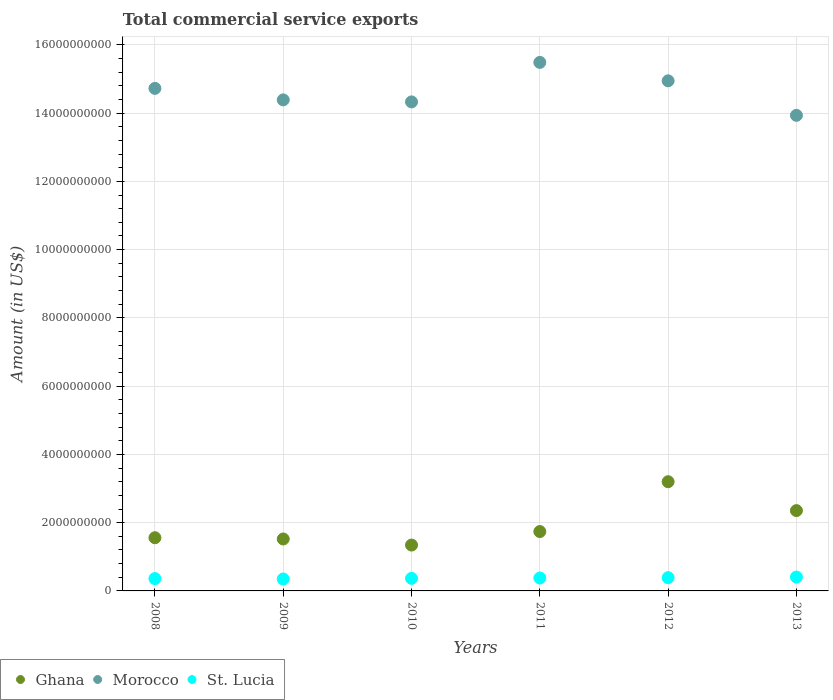How many different coloured dotlines are there?
Offer a terse response. 3. Is the number of dotlines equal to the number of legend labels?
Offer a very short reply. Yes. What is the total commercial service exports in Morocco in 2012?
Ensure brevity in your answer.  1.49e+1. Across all years, what is the maximum total commercial service exports in Ghana?
Make the answer very short. 3.20e+09. Across all years, what is the minimum total commercial service exports in Morocco?
Provide a short and direct response. 1.39e+1. In which year was the total commercial service exports in Ghana maximum?
Your response must be concise. 2012. What is the total total commercial service exports in St. Lucia in the graph?
Make the answer very short. 2.25e+09. What is the difference between the total commercial service exports in Ghana in 2008 and that in 2010?
Keep it short and to the point. 2.15e+08. What is the difference between the total commercial service exports in Ghana in 2009 and the total commercial service exports in Morocco in 2012?
Offer a very short reply. -1.34e+1. What is the average total commercial service exports in Morocco per year?
Provide a short and direct response. 1.46e+1. In the year 2008, what is the difference between the total commercial service exports in St. Lucia and total commercial service exports in Morocco?
Provide a short and direct response. -1.44e+1. What is the ratio of the total commercial service exports in Morocco in 2008 to that in 2009?
Give a very brief answer. 1.02. What is the difference between the highest and the second highest total commercial service exports in Ghana?
Provide a short and direct response. 8.47e+08. What is the difference between the highest and the lowest total commercial service exports in St. Lucia?
Offer a very short reply. 5.57e+07. Is the sum of the total commercial service exports in Morocco in 2008 and 2011 greater than the maximum total commercial service exports in Ghana across all years?
Ensure brevity in your answer.  Yes. Is the total commercial service exports in Morocco strictly greater than the total commercial service exports in Ghana over the years?
Keep it short and to the point. Yes. How many years are there in the graph?
Offer a very short reply. 6. What is the difference between two consecutive major ticks on the Y-axis?
Provide a succinct answer. 2.00e+09. Does the graph contain grids?
Your answer should be compact. Yes. Where does the legend appear in the graph?
Ensure brevity in your answer.  Bottom left. How many legend labels are there?
Make the answer very short. 3. How are the legend labels stacked?
Ensure brevity in your answer.  Horizontal. What is the title of the graph?
Offer a very short reply. Total commercial service exports. Does "Australia" appear as one of the legend labels in the graph?
Offer a terse response. No. What is the label or title of the Y-axis?
Provide a succinct answer. Amount (in US$). What is the Amount (in US$) in Ghana in 2008?
Provide a succinct answer. 1.56e+09. What is the Amount (in US$) of Morocco in 2008?
Your answer should be very brief. 1.47e+1. What is the Amount (in US$) in St. Lucia in 2008?
Ensure brevity in your answer.  3.62e+08. What is the Amount (in US$) of Ghana in 2009?
Your answer should be very brief. 1.52e+09. What is the Amount (in US$) in Morocco in 2009?
Provide a short and direct response. 1.44e+1. What is the Amount (in US$) in St. Lucia in 2009?
Ensure brevity in your answer.  3.50e+08. What is the Amount (in US$) of Ghana in 2010?
Your response must be concise. 1.34e+09. What is the Amount (in US$) of Morocco in 2010?
Provide a succinct answer. 1.43e+1. What is the Amount (in US$) of St. Lucia in 2010?
Offer a very short reply. 3.68e+08. What is the Amount (in US$) of Ghana in 2011?
Provide a short and direct response. 1.74e+09. What is the Amount (in US$) of Morocco in 2011?
Your answer should be very brief. 1.55e+1. What is the Amount (in US$) of St. Lucia in 2011?
Give a very brief answer. 3.78e+08. What is the Amount (in US$) of Ghana in 2012?
Make the answer very short. 3.20e+09. What is the Amount (in US$) in Morocco in 2012?
Offer a terse response. 1.49e+1. What is the Amount (in US$) in St. Lucia in 2012?
Make the answer very short. 3.89e+08. What is the Amount (in US$) in Ghana in 2013?
Ensure brevity in your answer.  2.35e+09. What is the Amount (in US$) of Morocco in 2013?
Provide a short and direct response. 1.39e+1. What is the Amount (in US$) of St. Lucia in 2013?
Provide a succinct answer. 4.06e+08. Across all years, what is the maximum Amount (in US$) of Ghana?
Your response must be concise. 3.20e+09. Across all years, what is the maximum Amount (in US$) of Morocco?
Ensure brevity in your answer.  1.55e+1. Across all years, what is the maximum Amount (in US$) of St. Lucia?
Your answer should be very brief. 4.06e+08. Across all years, what is the minimum Amount (in US$) of Ghana?
Keep it short and to the point. 1.34e+09. Across all years, what is the minimum Amount (in US$) of Morocco?
Give a very brief answer. 1.39e+1. Across all years, what is the minimum Amount (in US$) of St. Lucia?
Provide a succinct answer. 3.50e+08. What is the total Amount (in US$) of Ghana in the graph?
Provide a succinct answer. 1.17e+1. What is the total Amount (in US$) in Morocco in the graph?
Your answer should be very brief. 8.78e+1. What is the total Amount (in US$) of St. Lucia in the graph?
Ensure brevity in your answer.  2.25e+09. What is the difference between the Amount (in US$) of Ghana in 2008 and that in 2009?
Provide a succinct answer. 3.67e+07. What is the difference between the Amount (in US$) in Morocco in 2008 and that in 2009?
Provide a short and direct response. 3.37e+08. What is the difference between the Amount (in US$) of St. Lucia in 2008 and that in 2009?
Your answer should be compact. 1.12e+07. What is the difference between the Amount (in US$) of Ghana in 2008 and that in 2010?
Give a very brief answer. 2.15e+08. What is the difference between the Amount (in US$) in Morocco in 2008 and that in 2010?
Your answer should be compact. 3.96e+08. What is the difference between the Amount (in US$) of St. Lucia in 2008 and that in 2010?
Ensure brevity in your answer.  -6.13e+06. What is the difference between the Amount (in US$) of Ghana in 2008 and that in 2011?
Give a very brief answer. -1.81e+08. What is the difference between the Amount (in US$) in Morocco in 2008 and that in 2011?
Your answer should be compact. -7.61e+08. What is the difference between the Amount (in US$) of St. Lucia in 2008 and that in 2011?
Offer a terse response. -1.67e+07. What is the difference between the Amount (in US$) in Ghana in 2008 and that in 2012?
Offer a terse response. -1.64e+09. What is the difference between the Amount (in US$) of Morocco in 2008 and that in 2012?
Your response must be concise. -2.22e+08. What is the difference between the Amount (in US$) of St. Lucia in 2008 and that in 2012?
Give a very brief answer. -2.72e+07. What is the difference between the Amount (in US$) of Ghana in 2008 and that in 2013?
Provide a succinct answer. -7.95e+08. What is the difference between the Amount (in US$) in Morocco in 2008 and that in 2013?
Your answer should be compact. 7.90e+08. What is the difference between the Amount (in US$) in St. Lucia in 2008 and that in 2013?
Make the answer very short. -4.45e+07. What is the difference between the Amount (in US$) of Ghana in 2009 and that in 2010?
Your response must be concise. 1.78e+08. What is the difference between the Amount (in US$) in Morocco in 2009 and that in 2010?
Your answer should be compact. 5.92e+07. What is the difference between the Amount (in US$) in St. Lucia in 2009 and that in 2010?
Provide a short and direct response. -1.74e+07. What is the difference between the Amount (in US$) of Ghana in 2009 and that in 2011?
Offer a terse response. -2.18e+08. What is the difference between the Amount (in US$) of Morocco in 2009 and that in 2011?
Offer a terse response. -1.10e+09. What is the difference between the Amount (in US$) of St. Lucia in 2009 and that in 2011?
Make the answer very short. -2.79e+07. What is the difference between the Amount (in US$) in Ghana in 2009 and that in 2012?
Make the answer very short. -1.68e+09. What is the difference between the Amount (in US$) of Morocco in 2009 and that in 2012?
Keep it short and to the point. -5.58e+08. What is the difference between the Amount (in US$) in St. Lucia in 2009 and that in 2012?
Offer a terse response. -3.84e+07. What is the difference between the Amount (in US$) of Ghana in 2009 and that in 2013?
Provide a short and direct response. -8.31e+08. What is the difference between the Amount (in US$) of Morocco in 2009 and that in 2013?
Provide a short and direct response. 4.53e+08. What is the difference between the Amount (in US$) in St. Lucia in 2009 and that in 2013?
Ensure brevity in your answer.  -5.57e+07. What is the difference between the Amount (in US$) in Ghana in 2010 and that in 2011?
Your answer should be compact. -3.96e+08. What is the difference between the Amount (in US$) of Morocco in 2010 and that in 2011?
Give a very brief answer. -1.16e+09. What is the difference between the Amount (in US$) of St. Lucia in 2010 and that in 2011?
Offer a terse response. -1.05e+07. What is the difference between the Amount (in US$) in Ghana in 2010 and that in 2012?
Offer a terse response. -1.86e+09. What is the difference between the Amount (in US$) of Morocco in 2010 and that in 2012?
Ensure brevity in your answer.  -6.18e+08. What is the difference between the Amount (in US$) of St. Lucia in 2010 and that in 2012?
Offer a very short reply. -2.10e+07. What is the difference between the Amount (in US$) of Ghana in 2010 and that in 2013?
Keep it short and to the point. -1.01e+09. What is the difference between the Amount (in US$) of Morocco in 2010 and that in 2013?
Provide a short and direct response. 3.94e+08. What is the difference between the Amount (in US$) in St. Lucia in 2010 and that in 2013?
Ensure brevity in your answer.  -3.83e+07. What is the difference between the Amount (in US$) in Ghana in 2011 and that in 2012?
Give a very brief answer. -1.46e+09. What is the difference between the Amount (in US$) of Morocco in 2011 and that in 2012?
Make the answer very short. 5.40e+08. What is the difference between the Amount (in US$) in St. Lucia in 2011 and that in 2012?
Ensure brevity in your answer.  -1.05e+07. What is the difference between the Amount (in US$) of Ghana in 2011 and that in 2013?
Give a very brief answer. -6.14e+08. What is the difference between the Amount (in US$) in Morocco in 2011 and that in 2013?
Your answer should be compact. 1.55e+09. What is the difference between the Amount (in US$) in St. Lucia in 2011 and that in 2013?
Ensure brevity in your answer.  -2.78e+07. What is the difference between the Amount (in US$) in Ghana in 2012 and that in 2013?
Your answer should be compact. 8.47e+08. What is the difference between the Amount (in US$) of Morocco in 2012 and that in 2013?
Make the answer very short. 1.01e+09. What is the difference between the Amount (in US$) of St. Lucia in 2012 and that in 2013?
Provide a short and direct response. -1.73e+07. What is the difference between the Amount (in US$) of Ghana in 2008 and the Amount (in US$) of Morocco in 2009?
Provide a short and direct response. -1.28e+1. What is the difference between the Amount (in US$) in Ghana in 2008 and the Amount (in US$) in St. Lucia in 2009?
Give a very brief answer. 1.21e+09. What is the difference between the Amount (in US$) of Morocco in 2008 and the Amount (in US$) of St. Lucia in 2009?
Keep it short and to the point. 1.44e+1. What is the difference between the Amount (in US$) in Ghana in 2008 and the Amount (in US$) in Morocco in 2010?
Provide a succinct answer. -1.28e+1. What is the difference between the Amount (in US$) in Ghana in 2008 and the Amount (in US$) in St. Lucia in 2010?
Provide a succinct answer. 1.19e+09. What is the difference between the Amount (in US$) in Morocco in 2008 and the Amount (in US$) in St. Lucia in 2010?
Ensure brevity in your answer.  1.44e+1. What is the difference between the Amount (in US$) in Ghana in 2008 and the Amount (in US$) in Morocco in 2011?
Give a very brief answer. -1.39e+1. What is the difference between the Amount (in US$) of Ghana in 2008 and the Amount (in US$) of St. Lucia in 2011?
Give a very brief answer. 1.18e+09. What is the difference between the Amount (in US$) of Morocco in 2008 and the Amount (in US$) of St. Lucia in 2011?
Provide a short and direct response. 1.43e+1. What is the difference between the Amount (in US$) of Ghana in 2008 and the Amount (in US$) of Morocco in 2012?
Keep it short and to the point. -1.34e+1. What is the difference between the Amount (in US$) in Ghana in 2008 and the Amount (in US$) in St. Lucia in 2012?
Offer a very short reply. 1.17e+09. What is the difference between the Amount (in US$) of Morocco in 2008 and the Amount (in US$) of St. Lucia in 2012?
Your answer should be very brief. 1.43e+1. What is the difference between the Amount (in US$) in Ghana in 2008 and the Amount (in US$) in Morocco in 2013?
Provide a succinct answer. -1.24e+1. What is the difference between the Amount (in US$) in Ghana in 2008 and the Amount (in US$) in St. Lucia in 2013?
Give a very brief answer. 1.15e+09. What is the difference between the Amount (in US$) in Morocco in 2008 and the Amount (in US$) in St. Lucia in 2013?
Give a very brief answer. 1.43e+1. What is the difference between the Amount (in US$) in Ghana in 2009 and the Amount (in US$) in Morocco in 2010?
Your response must be concise. -1.28e+1. What is the difference between the Amount (in US$) in Ghana in 2009 and the Amount (in US$) in St. Lucia in 2010?
Provide a short and direct response. 1.15e+09. What is the difference between the Amount (in US$) of Morocco in 2009 and the Amount (in US$) of St. Lucia in 2010?
Give a very brief answer. 1.40e+1. What is the difference between the Amount (in US$) in Ghana in 2009 and the Amount (in US$) in Morocco in 2011?
Your answer should be very brief. -1.40e+1. What is the difference between the Amount (in US$) in Ghana in 2009 and the Amount (in US$) in St. Lucia in 2011?
Ensure brevity in your answer.  1.14e+09. What is the difference between the Amount (in US$) of Morocco in 2009 and the Amount (in US$) of St. Lucia in 2011?
Your response must be concise. 1.40e+1. What is the difference between the Amount (in US$) of Ghana in 2009 and the Amount (in US$) of Morocco in 2012?
Your answer should be very brief. -1.34e+1. What is the difference between the Amount (in US$) of Ghana in 2009 and the Amount (in US$) of St. Lucia in 2012?
Provide a short and direct response. 1.13e+09. What is the difference between the Amount (in US$) in Morocco in 2009 and the Amount (in US$) in St. Lucia in 2012?
Provide a short and direct response. 1.40e+1. What is the difference between the Amount (in US$) in Ghana in 2009 and the Amount (in US$) in Morocco in 2013?
Offer a very short reply. -1.24e+1. What is the difference between the Amount (in US$) in Ghana in 2009 and the Amount (in US$) in St. Lucia in 2013?
Offer a very short reply. 1.12e+09. What is the difference between the Amount (in US$) of Morocco in 2009 and the Amount (in US$) of St. Lucia in 2013?
Make the answer very short. 1.40e+1. What is the difference between the Amount (in US$) of Ghana in 2010 and the Amount (in US$) of Morocco in 2011?
Provide a short and direct response. -1.41e+1. What is the difference between the Amount (in US$) in Ghana in 2010 and the Amount (in US$) in St. Lucia in 2011?
Provide a succinct answer. 9.65e+08. What is the difference between the Amount (in US$) of Morocco in 2010 and the Amount (in US$) of St. Lucia in 2011?
Your response must be concise. 1.40e+1. What is the difference between the Amount (in US$) in Ghana in 2010 and the Amount (in US$) in Morocco in 2012?
Your answer should be very brief. -1.36e+1. What is the difference between the Amount (in US$) of Ghana in 2010 and the Amount (in US$) of St. Lucia in 2012?
Offer a terse response. 9.55e+08. What is the difference between the Amount (in US$) in Morocco in 2010 and the Amount (in US$) in St. Lucia in 2012?
Offer a terse response. 1.39e+1. What is the difference between the Amount (in US$) of Ghana in 2010 and the Amount (in US$) of Morocco in 2013?
Provide a short and direct response. -1.26e+1. What is the difference between the Amount (in US$) in Ghana in 2010 and the Amount (in US$) in St. Lucia in 2013?
Offer a very short reply. 9.38e+08. What is the difference between the Amount (in US$) of Morocco in 2010 and the Amount (in US$) of St. Lucia in 2013?
Your answer should be very brief. 1.39e+1. What is the difference between the Amount (in US$) in Ghana in 2011 and the Amount (in US$) in Morocco in 2012?
Offer a terse response. -1.32e+1. What is the difference between the Amount (in US$) in Ghana in 2011 and the Amount (in US$) in St. Lucia in 2012?
Keep it short and to the point. 1.35e+09. What is the difference between the Amount (in US$) in Morocco in 2011 and the Amount (in US$) in St. Lucia in 2012?
Keep it short and to the point. 1.51e+1. What is the difference between the Amount (in US$) in Ghana in 2011 and the Amount (in US$) in Morocco in 2013?
Provide a short and direct response. -1.22e+1. What is the difference between the Amount (in US$) in Ghana in 2011 and the Amount (in US$) in St. Lucia in 2013?
Your response must be concise. 1.33e+09. What is the difference between the Amount (in US$) in Morocco in 2011 and the Amount (in US$) in St. Lucia in 2013?
Provide a short and direct response. 1.51e+1. What is the difference between the Amount (in US$) in Ghana in 2012 and the Amount (in US$) in Morocco in 2013?
Give a very brief answer. -1.07e+1. What is the difference between the Amount (in US$) of Ghana in 2012 and the Amount (in US$) of St. Lucia in 2013?
Your answer should be very brief. 2.79e+09. What is the difference between the Amount (in US$) of Morocco in 2012 and the Amount (in US$) of St. Lucia in 2013?
Provide a succinct answer. 1.45e+1. What is the average Amount (in US$) in Ghana per year?
Offer a very short reply. 1.95e+09. What is the average Amount (in US$) of Morocco per year?
Make the answer very short. 1.46e+1. What is the average Amount (in US$) in St. Lucia per year?
Provide a succinct answer. 3.75e+08. In the year 2008, what is the difference between the Amount (in US$) in Ghana and Amount (in US$) in Morocco?
Your answer should be very brief. -1.32e+1. In the year 2008, what is the difference between the Amount (in US$) of Ghana and Amount (in US$) of St. Lucia?
Keep it short and to the point. 1.20e+09. In the year 2008, what is the difference between the Amount (in US$) in Morocco and Amount (in US$) in St. Lucia?
Your response must be concise. 1.44e+1. In the year 2009, what is the difference between the Amount (in US$) of Ghana and Amount (in US$) of Morocco?
Offer a very short reply. -1.29e+1. In the year 2009, what is the difference between the Amount (in US$) in Ghana and Amount (in US$) in St. Lucia?
Your response must be concise. 1.17e+09. In the year 2009, what is the difference between the Amount (in US$) of Morocco and Amount (in US$) of St. Lucia?
Keep it short and to the point. 1.40e+1. In the year 2010, what is the difference between the Amount (in US$) in Ghana and Amount (in US$) in Morocco?
Your answer should be compact. -1.30e+1. In the year 2010, what is the difference between the Amount (in US$) in Ghana and Amount (in US$) in St. Lucia?
Make the answer very short. 9.76e+08. In the year 2010, what is the difference between the Amount (in US$) in Morocco and Amount (in US$) in St. Lucia?
Give a very brief answer. 1.40e+1. In the year 2011, what is the difference between the Amount (in US$) of Ghana and Amount (in US$) of Morocco?
Keep it short and to the point. -1.37e+1. In the year 2011, what is the difference between the Amount (in US$) of Ghana and Amount (in US$) of St. Lucia?
Ensure brevity in your answer.  1.36e+09. In the year 2011, what is the difference between the Amount (in US$) in Morocco and Amount (in US$) in St. Lucia?
Keep it short and to the point. 1.51e+1. In the year 2012, what is the difference between the Amount (in US$) of Ghana and Amount (in US$) of Morocco?
Your answer should be compact. -1.17e+1. In the year 2012, what is the difference between the Amount (in US$) in Ghana and Amount (in US$) in St. Lucia?
Your answer should be very brief. 2.81e+09. In the year 2012, what is the difference between the Amount (in US$) in Morocco and Amount (in US$) in St. Lucia?
Offer a terse response. 1.46e+1. In the year 2013, what is the difference between the Amount (in US$) of Ghana and Amount (in US$) of Morocco?
Your response must be concise. -1.16e+1. In the year 2013, what is the difference between the Amount (in US$) in Ghana and Amount (in US$) in St. Lucia?
Your response must be concise. 1.95e+09. In the year 2013, what is the difference between the Amount (in US$) in Morocco and Amount (in US$) in St. Lucia?
Ensure brevity in your answer.  1.35e+1. What is the ratio of the Amount (in US$) in Ghana in 2008 to that in 2009?
Keep it short and to the point. 1.02. What is the ratio of the Amount (in US$) of Morocco in 2008 to that in 2009?
Provide a short and direct response. 1.02. What is the ratio of the Amount (in US$) of St. Lucia in 2008 to that in 2009?
Your response must be concise. 1.03. What is the ratio of the Amount (in US$) of Ghana in 2008 to that in 2010?
Your answer should be compact. 1.16. What is the ratio of the Amount (in US$) in Morocco in 2008 to that in 2010?
Provide a succinct answer. 1.03. What is the ratio of the Amount (in US$) in St. Lucia in 2008 to that in 2010?
Ensure brevity in your answer.  0.98. What is the ratio of the Amount (in US$) of Ghana in 2008 to that in 2011?
Your answer should be compact. 0.9. What is the ratio of the Amount (in US$) of Morocco in 2008 to that in 2011?
Offer a terse response. 0.95. What is the ratio of the Amount (in US$) of St. Lucia in 2008 to that in 2011?
Make the answer very short. 0.96. What is the ratio of the Amount (in US$) in Ghana in 2008 to that in 2012?
Keep it short and to the point. 0.49. What is the ratio of the Amount (in US$) in Morocco in 2008 to that in 2012?
Provide a succinct answer. 0.99. What is the ratio of the Amount (in US$) in St. Lucia in 2008 to that in 2012?
Give a very brief answer. 0.93. What is the ratio of the Amount (in US$) of Ghana in 2008 to that in 2013?
Ensure brevity in your answer.  0.66. What is the ratio of the Amount (in US$) in Morocco in 2008 to that in 2013?
Your answer should be very brief. 1.06. What is the ratio of the Amount (in US$) of St. Lucia in 2008 to that in 2013?
Give a very brief answer. 0.89. What is the ratio of the Amount (in US$) of Ghana in 2009 to that in 2010?
Your response must be concise. 1.13. What is the ratio of the Amount (in US$) of St. Lucia in 2009 to that in 2010?
Your response must be concise. 0.95. What is the ratio of the Amount (in US$) in Ghana in 2009 to that in 2011?
Your answer should be very brief. 0.87. What is the ratio of the Amount (in US$) in Morocco in 2009 to that in 2011?
Make the answer very short. 0.93. What is the ratio of the Amount (in US$) of St. Lucia in 2009 to that in 2011?
Your answer should be compact. 0.93. What is the ratio of the Amount (in US$) of Ghana in 2009 to that in 2012?
Offer a terse response. 0.48. What is the ratio of the Amount (in US$) of Morocco in 2009 to that in 2012?
Your answer should be very brief. 0.96. What is the ratio of the Amount (in US$) of St. Lucia in 2009 to that in 2012?
Offer a very short reply. 0.9. What is the ratio of the Amount (in US$) in Ghana in 2009 to that in 2013?
Provide a short and direct response. 0.65. What is the ratio of the Amount (in US$) in Morocco in 2009 to that in 2013?
Your answer should be compact. 1.03. What is the ratio of the Amount (in US$) of St. Lucia in 2009 to that in 2013?
Give a very brief answer. 0.86. What is the ratio of the Amount (in US$) of Ghana in 2010 to that in 2011?
Your answer should be compact. 0.77. What is the ratio of the Amount (in US$) of Morocco in 2010 to that in 2011?
Your response must be concise. 0.93. What is the ratio of the Amount (in US$) in St. Lucia in 2010 to that in 2011?
Provide a short and direct response. 0.97. What is the ratio of the Amount (in US$) in Ghana in 2010 to that in 2012?
Your response must be concise. 0.42. What is the ratio of the Amount (in US$) of Morocco in 2010 to that in 2012?
Provide a succinct answer. 0.96. What is the ratio of the Amount (in US$) of St. Lucia in 2010 to that in 2012?
Your answer should be very brief. 0.95. What is the ratio of the Amount (in US$) in Ghana in 2010 to that in 2013?
Ensure brevity in your answer.  0.57. What is the ratio of the Amount (in US$) in Morocco in 2010 to that in 2013?
Make the answer very short. 1.03. What is the ratio of the Amount (in US$) of St. Lucia in 2010 to that in 2013?
Your answer should be very brief. 0.91. What is the ratio of the Amount (in US$) of Ghana in 2011 to that in 2012?
Provide a succinct answer. 0.54. What is the ratio of the Amount (in US$) of Morocco in 2011 to that in 2012?
Offer a very short reply. 1.04. What is the ratio of the Amount (in US$) in St. Lucia in 2011 to that in 2012?
Your answer should be compact. 0.97. What is the ratio of the Amount (in US$) of Ghana in 2011 to that in 2013?
Your answer should be compact. 0.74. What is the ratio of the Amount (in US$) of Morocco in 2011 to that in 2013?
Provide a succinct answer. 1.11. What is the ratio of the Amount (in US$) of St. Lucia in 2011 to that in 2013?
Provide a succinct answer. 0.93. What is the ratio of the Amount (in US$) of Ghana in 2012 to that in 2013?
Provide a succinct answer. 1.36. What is the ratio of the Amount (in US$) in Morocco in 2012 to that in 2013?
Make the answer very short. 1.07. What is the ratio of the Amount (in US$) of St. Lucia in 2012 to that in 2013?
Provide a succinct answer. 0.96. What is the difference between the highest and the second highest Amount (in US$) of Ghana?
Offer a terse response. 8.47e+08. What is the difference between the highest and the second highest Amount (in US$) of Morocco?
Ensure brevity in your answer.  5.40e+08. What is the difference between the highest and the second highest Amount (in US$) of St. Lucia?
Provide a short and direct response. 1.73e+07. What is the difference between the highest and the lowest Amount (in US$) of Ghana?
Make the answer very short. 1.86e+09. What is the difference between the highest and the lowest Amount (in US$) of Morocco?
Offer a very short reply. 1.55e+09. What is the difference between the highest and the lowest Amount (in US$) in St. Lucia?
Make the answer very short. 5.57e+07. 